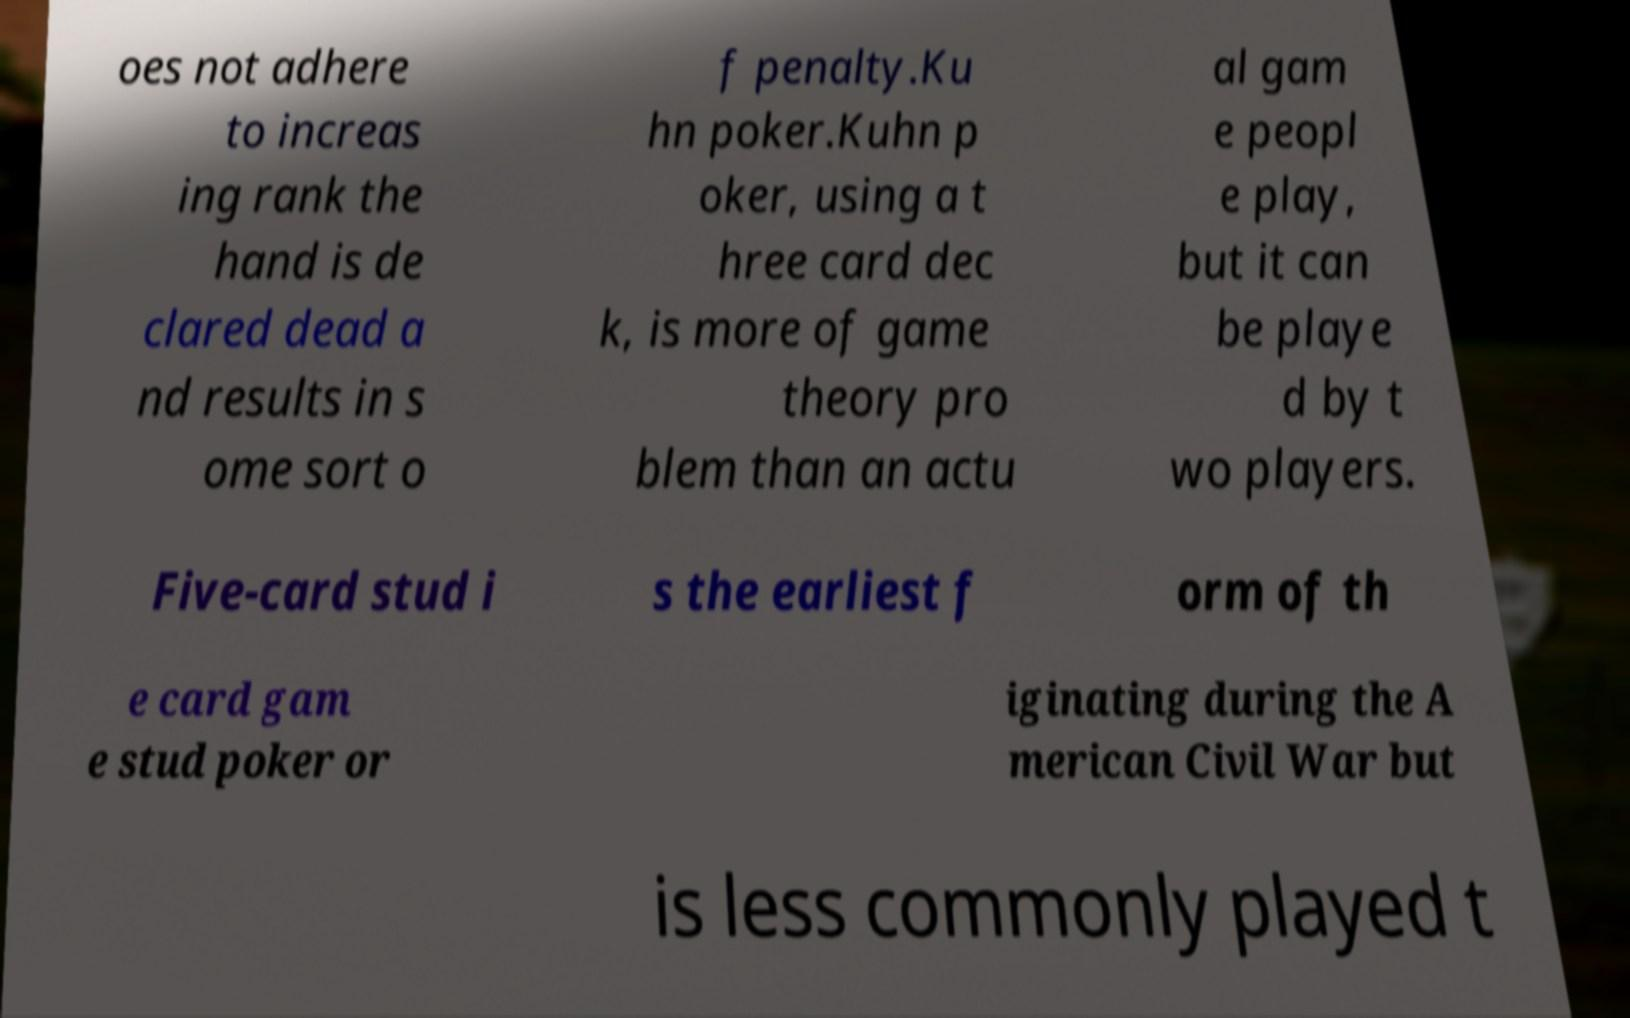Can you read and provide the text displayed in the image?This photo seems to have some interesting text. Can you extract and type it out for me? oes not adhere to increas ing rank the hand is de clared dead a nd results in s ome sort o f penalty.Ku hn poker.Kuhn p oker, using a t hree card dec k, is more of game theory pro blem than an actu al gam e peopl e play, but it can be playe d by t wo players. Five-card stud i s the earliest f orm of th e card gam e stud poker or iginating during the A merican Civil War but is less commonly played t 